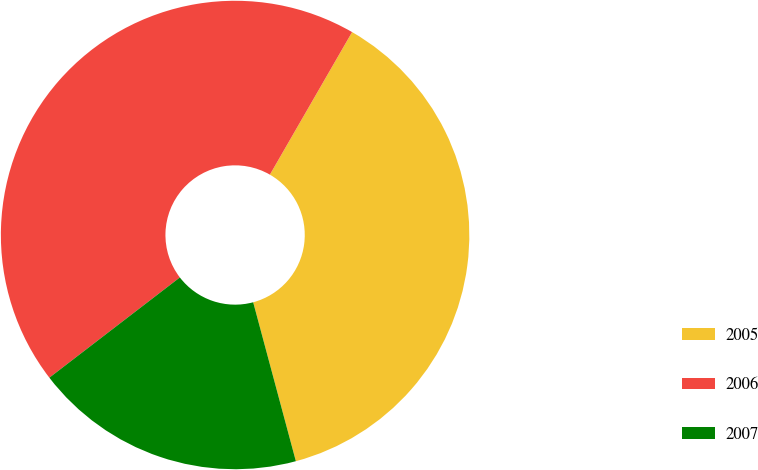Convert chart to OTSL. <chart><loc_0><loc_0><loc_500><loc_500><pie_chart><fcel>2005<fcel>2006<fcel>2007<nl><fcel>37.5%<fcel>43.75%<fcel>18.75%<nl></chart> 